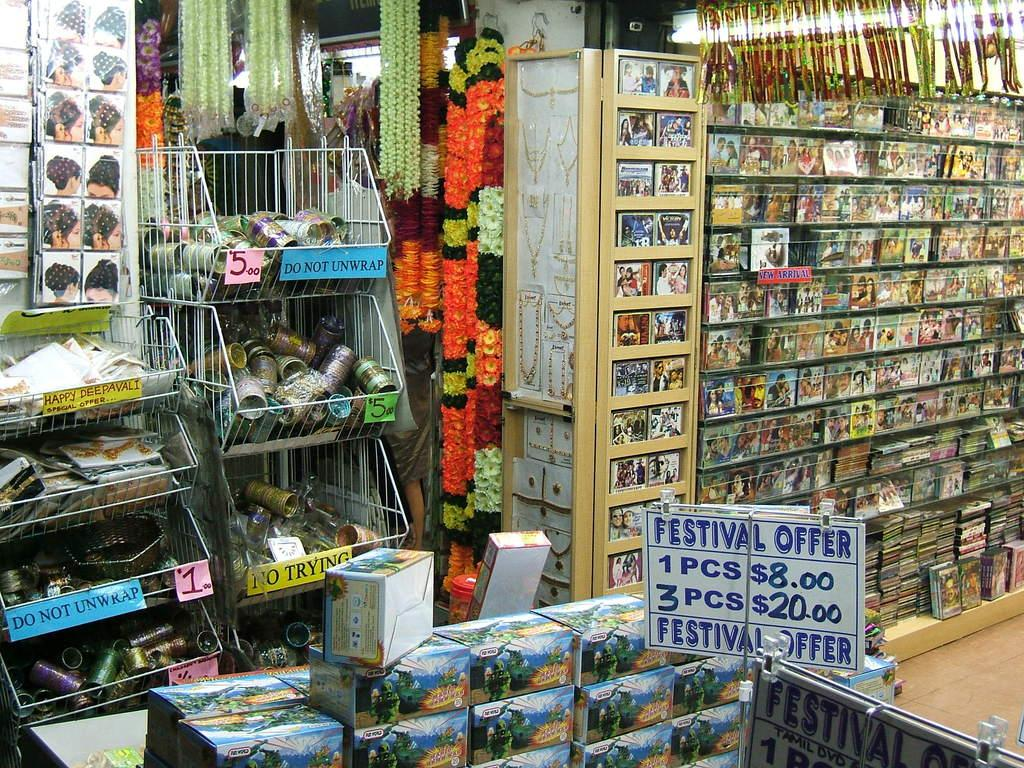<image>
Provide a brief description of the given image. A store with a display advertising a festival offer 